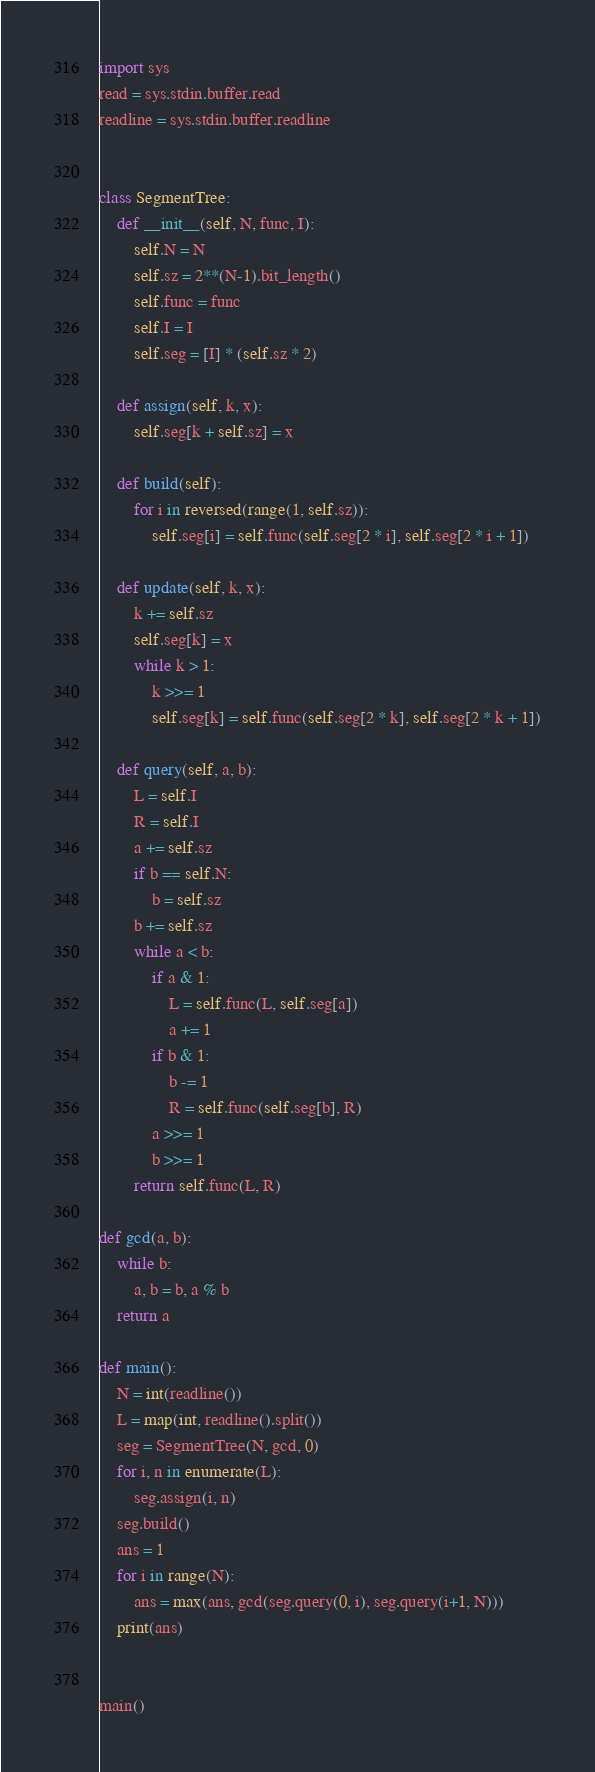<code> <loc_0><loc_0><loc_500><loc_500><_Python_>import sys
read = sys.stdin.buffer.read
readline = sys.stdin.buffer.readline


class SegmentTree:
    def __init__(self, N, func, I):
        self.N = N
        self.sz = 2**(N-1).bit_length()
        self.func = func
        self.I = I
        self.seg = [I] * (self.sz * 2)

    def assign(self, k, x):
        self.seg[k + self.sz] = x

    def build(self):
        for i in reversed(range(1, self.sz)):
            self.seg[i] = self.func(self.seg[2 * i], self.seg[2 * i + 1])

    def update(self, k, x):
        k += self.sz
        self.seg[k] = x
        while k > 1:
            k >>= 1
            self.seg[k] = self.func(self.seg[2 * k], self.seg[2 * k + 1])

    def query(self, a, b):
        L = self.I
        R = self.I
        a += self.sz
        if b == self.N:
            b = self.sz
        b += self.sz
        while a < b:
            if a & 1:
                L = self.func(L, self.seg[a])
                a += 1
            if b & 1:
                b -= 1
                R = self.func(self.seg[b], R)
            a >>= 1
            b >>= 1
        return self.func(L, R)

def gcd(a, b):
    while b:
        a, b = b, a % b
    return a

def main():
    N = int(readline())
    L = map(int, readline().split())
    seg = SegmentTree(N, gcd, 0)
    for i, n in enumerate(L):
        seg.assign(i, n)
    seg.build()
    ans = 1
    for i in range(N):
        ans = max(ans, gcd(seg.query(0, i), seg.query(i+1, N)))
    print(ans)


main()
</code> 